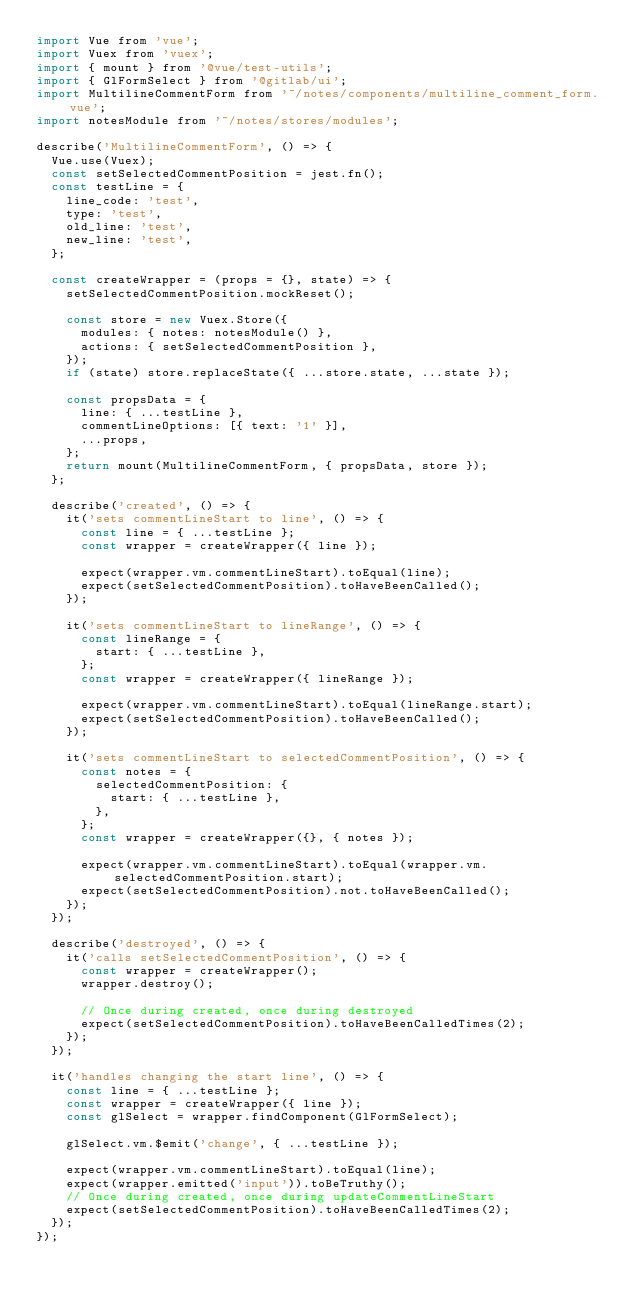Convert code to text. <code><loc_0><loc_0><loc_500><loc_500><_JavaScript_>import Vue from 'vue';
import Vuex from 'vuex';
import { mount } from '@vue/test-utils';
import { GlFormSelect } from '@gitlab/ui';
import MultilineCommentForm from '~/notes/components/multiline_comment_form.vue';
import notesModule from '~/notes/stores/modules';

describe('MultilineCommentForm', () => {
  Vue.use(Vuex);
  const setSelectedCommentPosition = jest.fn();
  const testLine = {
    line_code: 'test',
    type: 'test',
    old_line: 'test',
    new_line: 'test',
  };

  const createWrapper = (props = {}, state) => {
    setSelectedCommentPosition.mockReset();

    const store = new Vuex.Store({
      modules: { notes: notesModule() },
      actions: { setSelectedCommentPosition },
    });
    if (state) store.replaceState({ ...store.state, ...state });

    const propsData = {
      line: { ...testLine },
      commentLineOptions: [{ text: '1' }],
      ...props,
    };
    return mount(MultilineCommentForm, { propsData, store });
  };

  describe('created', () => {
    it('sets commentLineStart to line', () => {
      const line = { ...testLine };
      const wrapper = createWrapper({ line });

      expect(wrapper.vm.commentLineStart).toEqual(line);
      expect(setSelectedCommentPosition).toHaveBeenCalled();
    });

    it('sets commentLineStart to lineRange', () => {
      const lineRange = {
        start: { ...testLine },
      };
      const wrapper = createWrapper({ lineRange });

      expect(wrapper.vm.commentLineStart).toEqual(lineRange.start);
      expect(setSelectedCommentPosition).toHaveBeenCalled();
    });

    it('sets commentLineStart to selectedCommentPosition', () => {
      const notes = {
        selectedCommentPosition: {
          start: { ...testLine },
        },
      };
      const wrapper = createWrapper({}, { notes });

      expect(wrapper.vm.commentLineStart).toEqual(wrapper.vm.selectedCommentPosition.start);
      expect(setSelectedCommentPosition).not.toHaveBeenCalled();
    });
  });

  describe('destroyed', () => {
    it('calls setSelectedCommentPosition', () => {
      const wrapper = createWrapper();
      wrapper.destroy();

      // Once during created, once during destroyed
      expect(setSelectedCommentPosition).toHaveBeenCalledTimes(2);
    });
  });

  it('handles changing the start line', () => {
    const line = { ...testLine };
    const wrapper = createWrapper({ line });
    const glSelect = wrapper.findComponent(GlFormSelect);

    glSelect.vm.$emit('change', { ...testLine });

    expect(wrapper.vm.commentLineStart).toEqual(line);
    expect(wrapper.emitted('input')).toBeTruthy();
    // Once during created, once during updateCommentLineStart
    expect(setSelectedCommentPosition).toHaveBeenCalledTimes(2);
  });
});
</code> 